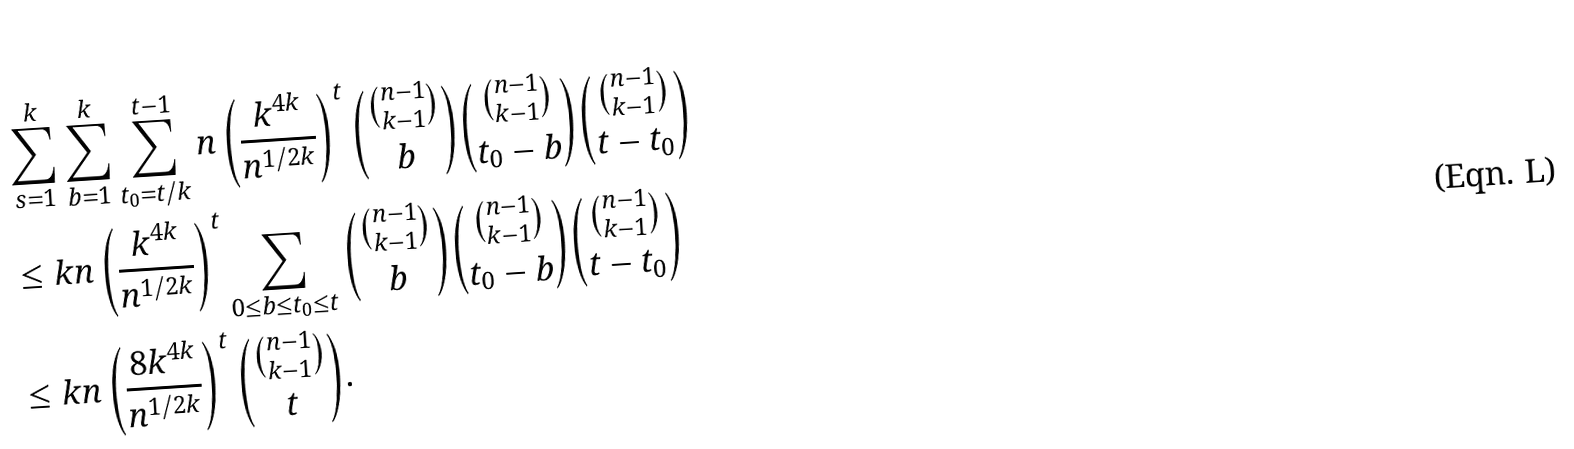Convert formula to latex. <formula><loc_0><loc_0><loc_500><loc_500>& \sum _ { s = 1 } ^ { k } \sum _ { b = 1 } ^ { k } \sum _ { t _ { 0 } = t / k } ^ { t - 1 } n \left ( \frac { k ^ { 4 k } } { n ^ { 1 / 2 k } } \right ) ^ { t } \binom { \binom { n - 1 } { k - 1 } } { b } \binom { \binom { n - 1 } { k - 1 } } { t _ { 0 } - b } \binom { \binom { n - 1 } { k - 1 } } { t - t _ { 0 } } \\ & \leq k n \left ( \frac { k ^ { 4 k } } { n ^ { 1 / 2 k } } \right ) ^ { t } \sum _ { 0 \leq b \leq t _ { 0 } \leq t } \binom { \binom { n - 1 } { k - 1 } } { b } \binom { \binom { n - 1 } { k - 1 } } { t _ { 0 } - b } \binom { \binom { n - 1 } { k - 1 } } { t - t _ { 0 } } \\ & \leq k n \left ( \frac { 8 k ^ { 4 k } } { n ^ { 1 / 2 k } } \right ) ^ { t } \binom { \binom { n - 1 } { k - 1 } } { t } .</formula> 